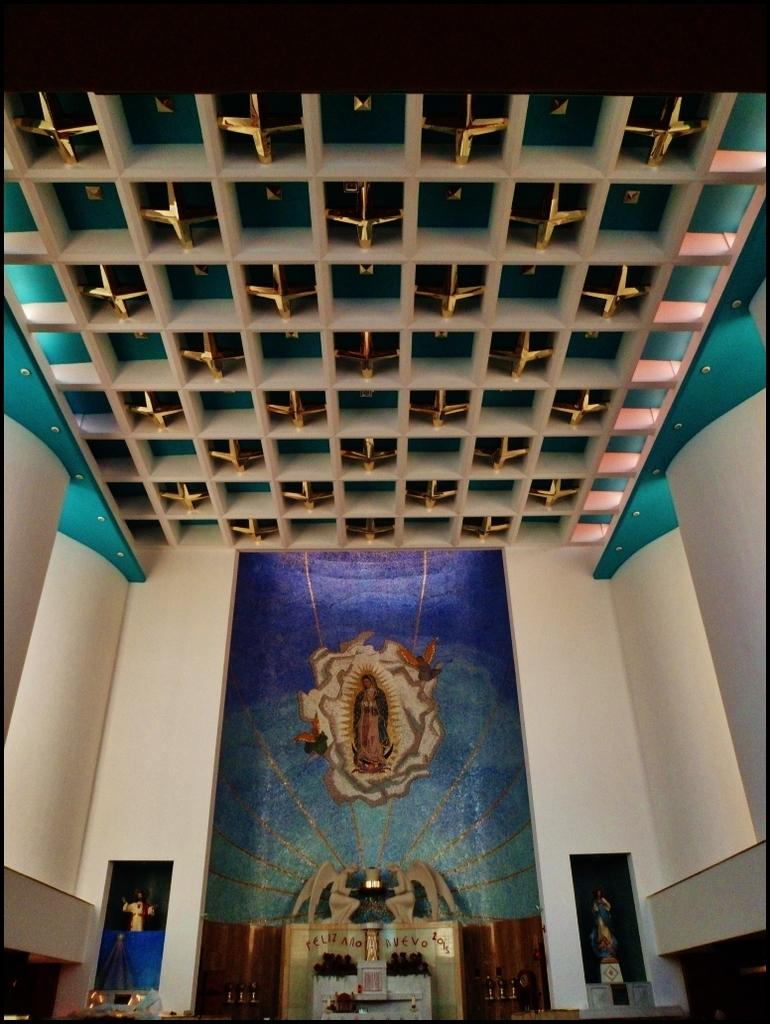What type of location is depicted in the image? The image is an inside view of a church. What color is the wall in the front of the image? The wall in the front of the image is blue. How is the ceiling of the church designed? The ceiling is golden with wooden rafters. What lighting feature is present on the ceiling? Spotlights are present on the ceiling. Can you see any balloons floating near the ceiling in the image? No, there are no balloons present in the image. What type of wire is used to hang the car from the ceiling in the image? There is no car present in the image; it is an inside view of a church with a golden ceiling and wooden rafters. 